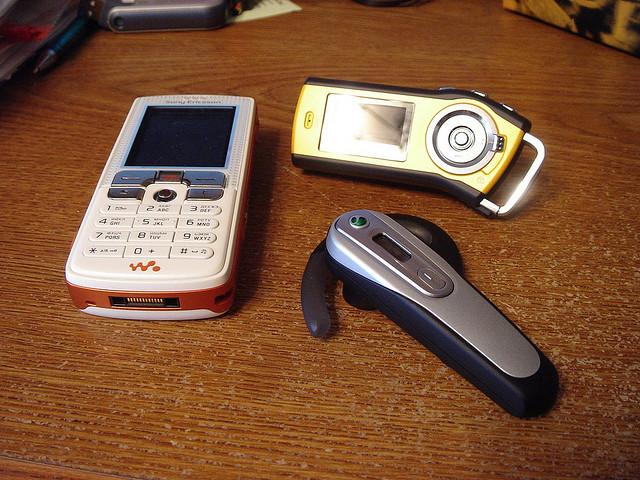Are these electronic devices dated?
Be succinct. Yes. How many electronics are displayed?
Quick response, please. 3. Are these modern devices?
Be succinct. Yes. How many electronics are in this photo?
Write a very short answer. 3. What color is the phone?
Answer briefly. White. Which of these 3 devices has the ability to place phone calls?
Short answer required. Cell phone. 